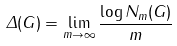<formula> <loc_0><loc_0><loc_500><loc_500>\Delta ( G ) = \lim _ { m \rightarrow \infty } \frac { \log N _ { m } ( G ) } { m }</formula> 